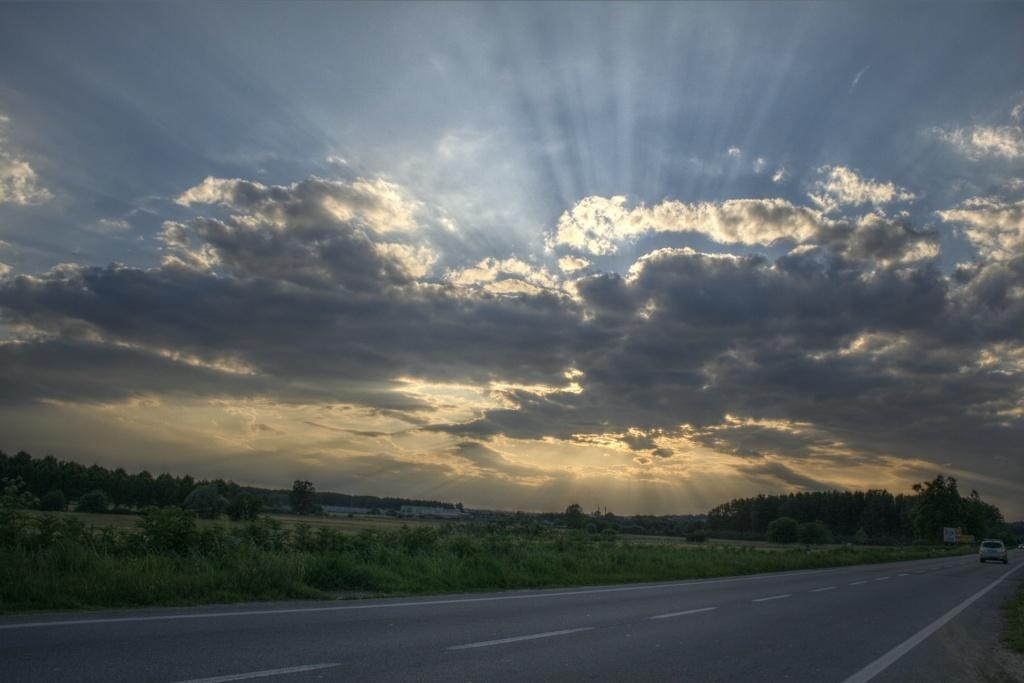What is the main subject of the image? There is there a vehicle on the road in the image? What can be seen in the background of the image? In the background of the image, there are trees, at least one building, grass, plants, and the sky. What is the condition of the sky in the image? The sky is visible in the background of the image, and clouds are present. Can you tell me how many poisonous plants are present in the image? There is no mention of poisonous plants in the image, so it is not possible to determine their number. Is there a person walking in the park in the image? There is no park or person walking in the image; it features a vehicle on the road with a background that includes trees, buildings, grass, plants, and the sky. 